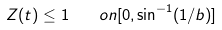<formula> <loc_0><loc_0><loc_500><loc_500>Z ( t ) \leq 1 \quad o n [ 0 , \sin ^ { - 1 } ( 1 / b ) ]</formula> 